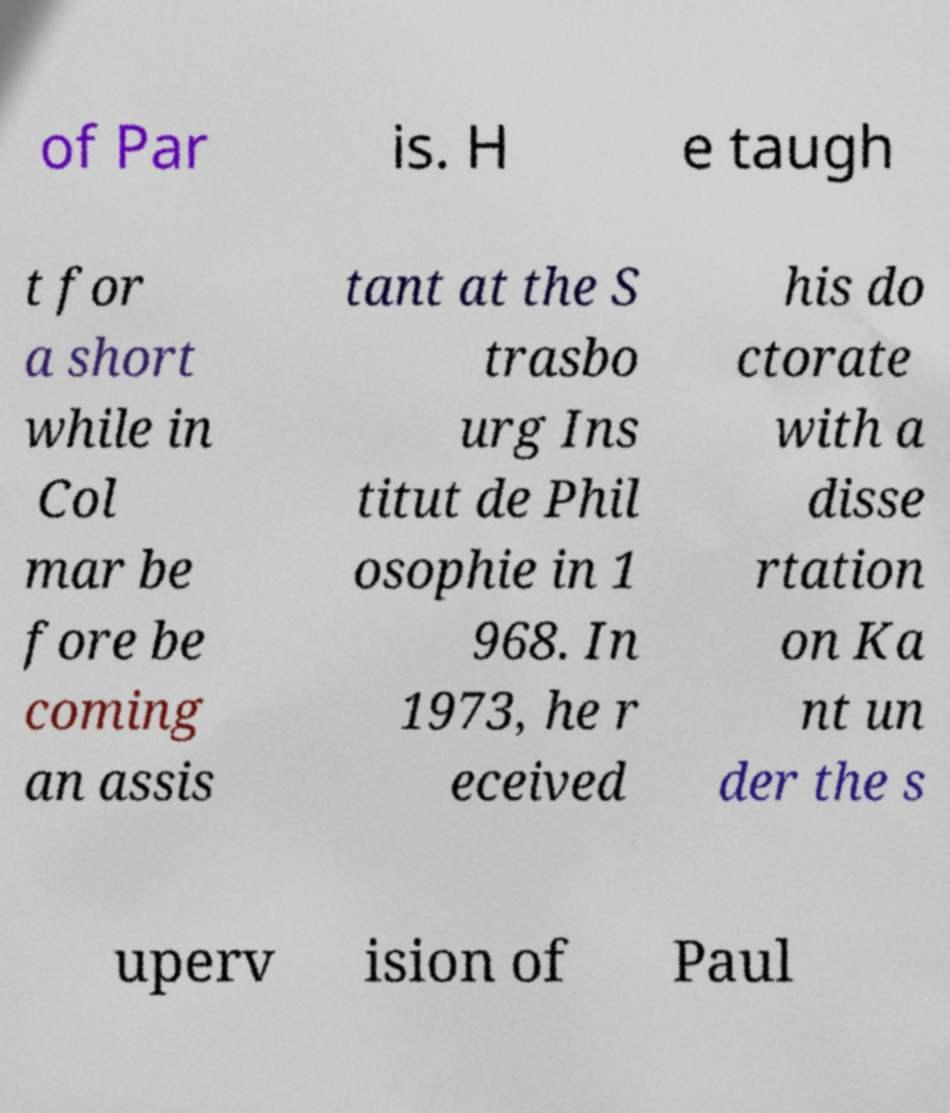Please identify and transcribe the text found in this image. of Par is. H e taugh t for a short while in Col mar be fore be coming an assis tant at the S trasbo urg Ins titut de Phil osophie in 1 968. In 1973, he r eceived his do ctorate with a disse rtation on Ka nt un der the s uperv ision of Paul 